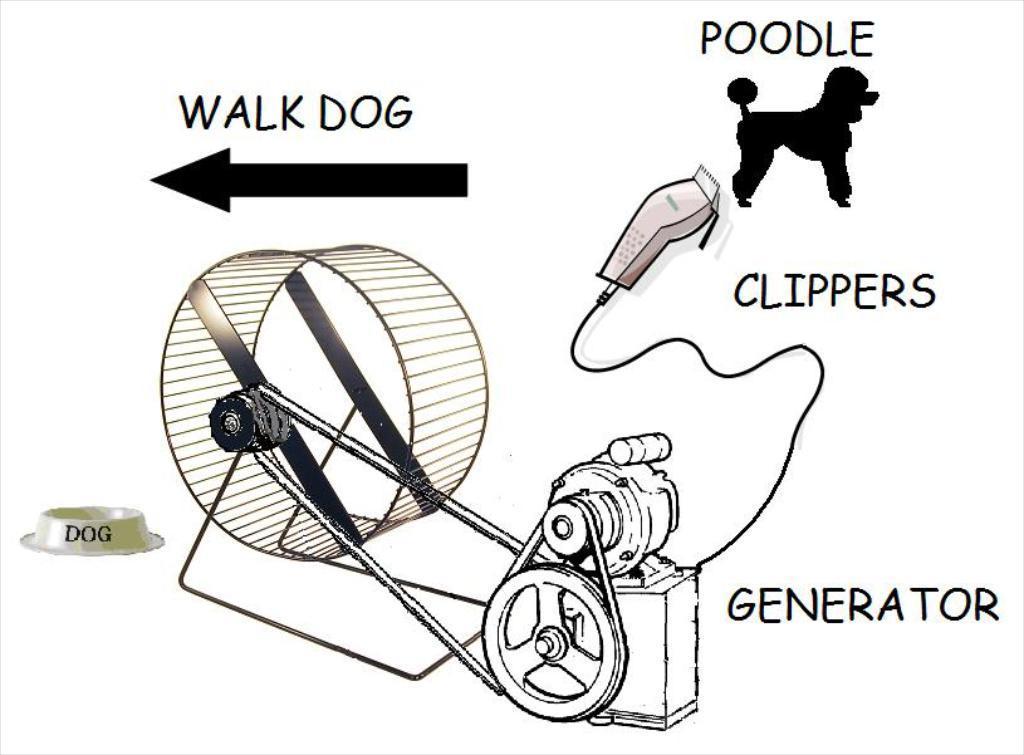Could you give a brief overview of what you see in this image? In the image we can see a generator and clipper and poodle drawing. 